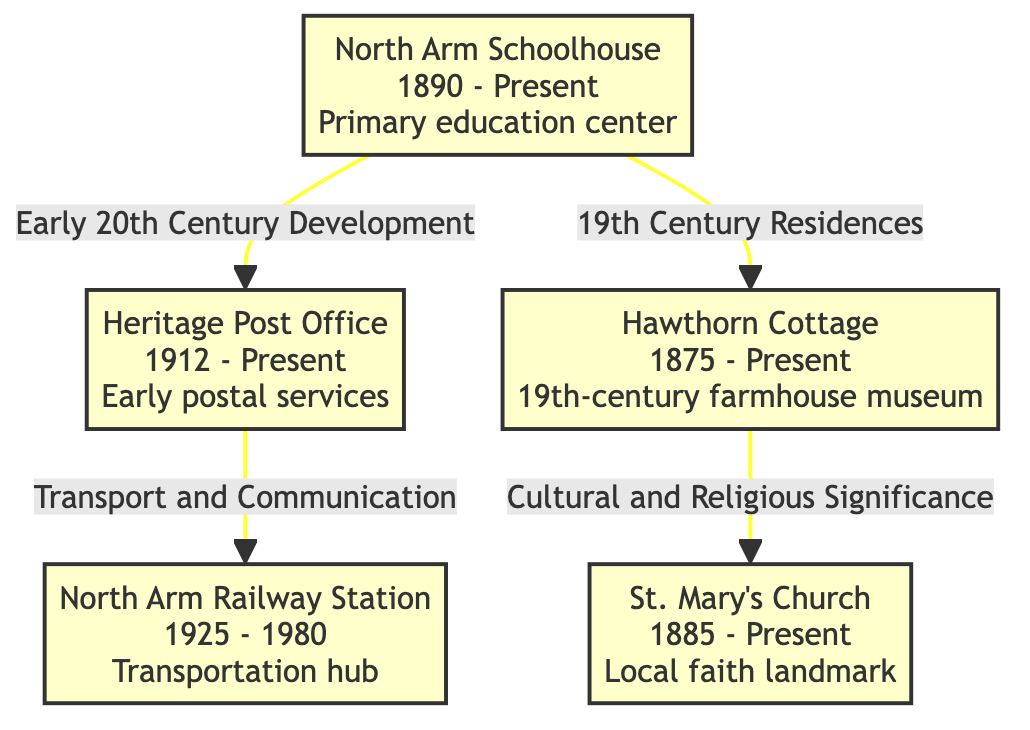What is the founding year of North Arm Schoolhouse? The diagram indicates that the North Arm Schoolhouse was established in 1890, which is clearly labeled in the description of the node.
Answer: 1890 How many historical landmarks are displayed in the diagram? By counting the nodes in the diagram dedicated to historical sites, there are five landmarks listed: North Arm Schoolhouse, Heritage Post Office, North Arm Railway Station, Hawthorn Cottage, and St. Mary's Church.
Answer: 5 Which landmark is associated with early postal services? The Heritage Post Office node describes it as an "Early postal services," indicating its significance in that area.
Answer: Heritage Post Office What type of structure is Hawthorn Cottage described as? According to the node for Hawthorn Cottage, it is characterized as a "19th-century farmhouse museum," specifying its historical relevance.
Answer: 19th-century farmhouse museum Which site has a relationship with transport and communication? The diagram connects the Heritage Post Office to the North Arm Railway Station through the label "Transport and Communication," indicating its role.
Answer: North Arm Railway Station Which church is listed as a local faith landmark? The description of St. Mary's Church explicitly states that it is a "Local faith landmark," confirming its purpose.
Answer: St. Mary's Church What is the timeline of the North Arm Railway Station? The node for North Arm Railway Station provides the timeline as "1925 - 1980," indicating it was operational during those years.
Answer: 1925 - 1980 Which landmark is linked to 19th Century Residences? The North Arm Schoolhouse node indicates a connection to Hawthorn Cottage with the label "19th Century Residences," demonstrating their historical ties.
Answer: Hawthorn Cottage What year was St. Mary's Church founded? The diagram depicts that St. Mary's Church was founded in 1885, noted specifically in the description.
Answer: 1885 